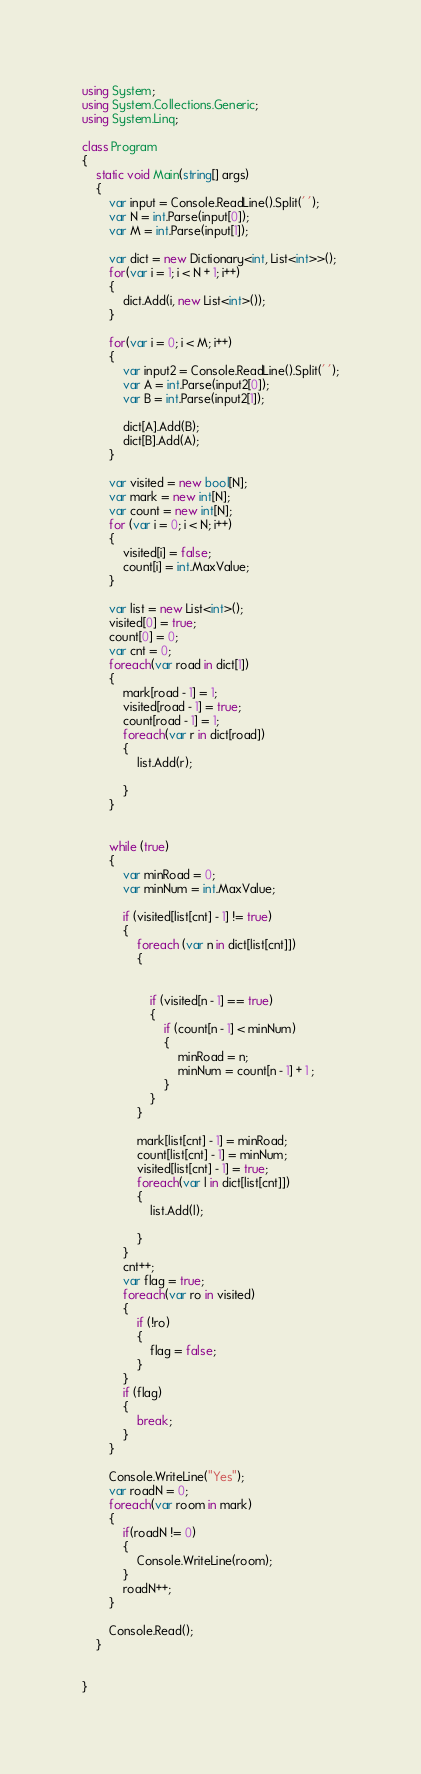<code> <loc_0><loc_0><loc_500><loc_500><_C#_>using System;
using System.Collections.Generic;
using System.Linq;

class Program
{
    static void Main(string[] args)
    {
        var input = Console.ReadLine().Split(' ');
        var N = int.Parse(input[0]);
        var M = int.Parse(input[1]);

        var dict = new Dictionary<int, List<int>>();
        for(var i = 1; i < N + 1; i++)
        {
            dict.Add(i, new List<int>());
        }

        for(var i = 0; i < M; i++)
        {
            var input2 = Console.ReadLine().Split(' ');
            var A = int.Parse(input2[0]);
            var B = int.Parse(input2[1]);

            dict[A].Add(B);
            dict[B].Add(A);
        }

        var visited = new bool[N];
        var mark = new int[N];
        var count = new int[N];
        for (var i = 0; i < N; i++)
        {
            visited[i] = false;
            count[i] = int.MaxValue;
        }

        var list = new List<int>();
        visited[0] = true;
        count[0] = 0;
        var cnt = 0;
        foreach(var road in dict[1])
        {
            mark[road - 1] = 1;
            visited[road - 1] = true;
            count[road - 1] = 1;
            foreach(var r in dict[road])
            {
                list.Add(r);

            }
        }


        while (true)
        {
            var minRoad = 0;
            var minNum = int.MaxValue;

            if (visited[list[cnt] - 1] != true)
            {
                foreach (var n in dict[list[cnt]])
                {


                    if (visited[n - 1] == true)
                    {
                        if (count[n - 1] < minNum)
                        {
                            minRoad = n;
                            minNum = count[n - 1] + 1 ;
                        }
                    }
                }

                mark[list[cnt] - 1] = minRoad;
                count[list[cnt] - 1] = minNum;
                visited[list[cnt] - 1] = true;
                foreach(var l in dict[list[cnt]])
                {
                    list.Add(l);

                }
            }
            cnt++;
            var flag = true;
            foreach(var ro in visited)
            {
                if (!ro)
                {
                    flag = false;
                }
            }
            if (flag)
            {
                break;
            }
        }

        Console.WriteLine("Yes");
        var roadN = 0;
        foreach(var room in mark)
        {
            if(roadN != 0)
            {
                Console.WriteLine(room);
            }
            roadN++;
        }

        Console.Read();
    }


}

</code> 